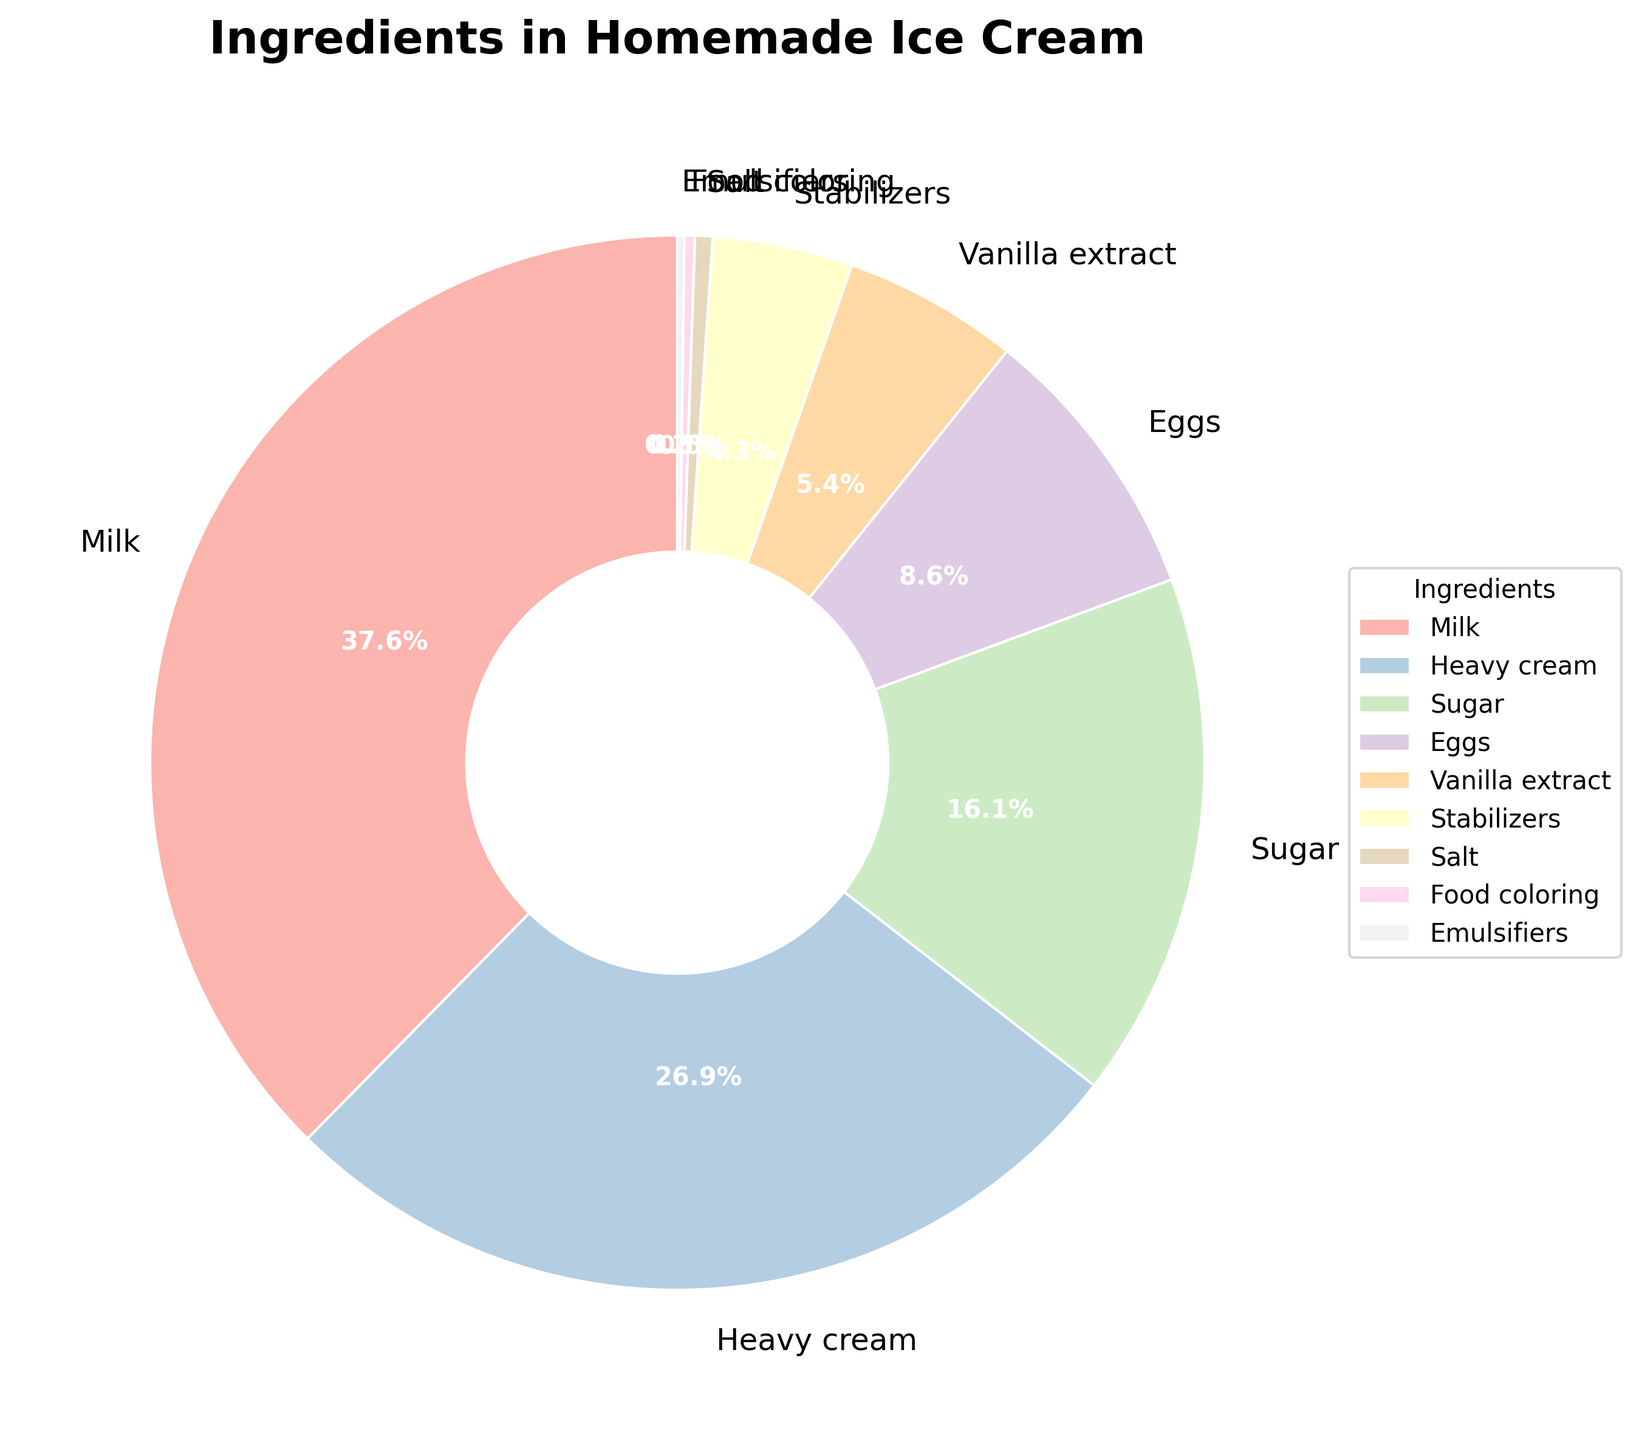What is the percentage of Milk and Heavy cream combined? To find the total percentage of Milk and Heavy cream combined, add their individual percentages: Milk (35%) + Heavy cream (25%) = 60%
Answer: 60% Which ingredient is used in the smallest percentage? By observing the pie chart, the smallest wedge corresponds to the ingredient with the smallest percentage. The smallest percentage is 0.2%, which is assigned to Emulsifiers.
Answer: Emulsifiers How much more Milk is used than Sugar? First, observe the percentages for Milk and Sugar. Milk is 35%, and Sugar is 15%. Subtract the percentage of Sugar from Milk: 35% - 15% = 20%
Answer: 20% Which has a larger percentage, Eggs or Vanilla extract? Compare the slices for Eggs and Vanilla extract. Eggs have a percentage of 8%, while Vanilla extract has a percentage of 5%. Therefore, Eggs have a larger percentage than Vanilla extract.
Answer: Eggs If you were to combine the percentages for Stabilizers and Salt, would it be greater than Sugar? Stabilizers are 4% and Salt is 0.5%. Combining them gives 4% + 0.5% = 4.5%. To compare with Sugar, which is 15%, 4.5% is less than 15%.
Answer: No Which ingredient besides Milk and Heavy cream has the largest percentage? After Milk (35%) and Heavy cream (25%), the next highest percentage is Sugar at 15%.
Answer: Sugar What is the combined percentage of all stabilizing and enhancing agents? (Stabilizers, Emulsifiers, Salt, Food coloring) Add the percentages for Stabilizers (4%), Emulsifiers (0.2%), Salt (0.5%), and Food coloring (0.3%): 4% + 0.2% + 0.5% + 0.3% = 5%
Answer: 5% Are the combined percentages of Eggs, Vanilla extract, and Sugar greater than 30%? Add the percentages for Eggs (8%), Vanilla extract (5%), and Sugar (15%): 8% + 5% + 15% = 28%, which is less than 30%.
Answer: No What ingredient makes up exactly 8% of the total? Observing the pie chart, we find that Eggs make up exactly 8% of the total.
Answer: Eggs How much percentage is contributed by coloring and flavoring agents? (Vanilla extract and Food coloring) Add the percentages for Vanilla extract (5%) and Food coloring (0.3%): 5% + 0.3% = 5.3%
Answer: 5.3% 